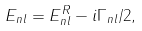<formula> <loc_0><loc_0><loc_500><loc_500>E _ { n l } = E _ { n l } ^ { R } - i \Gamma _ { n l } / 2 ,</formula> 